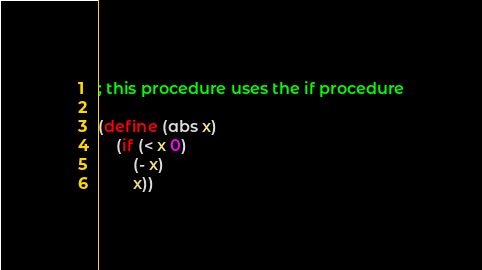<code> <loc_0><loc_0><loc_500><loc_500><_Scheme_>; this procedure uses the if procedure

(define (abs x)
    (if (< x 0)
        (- x)
        x))</code> 